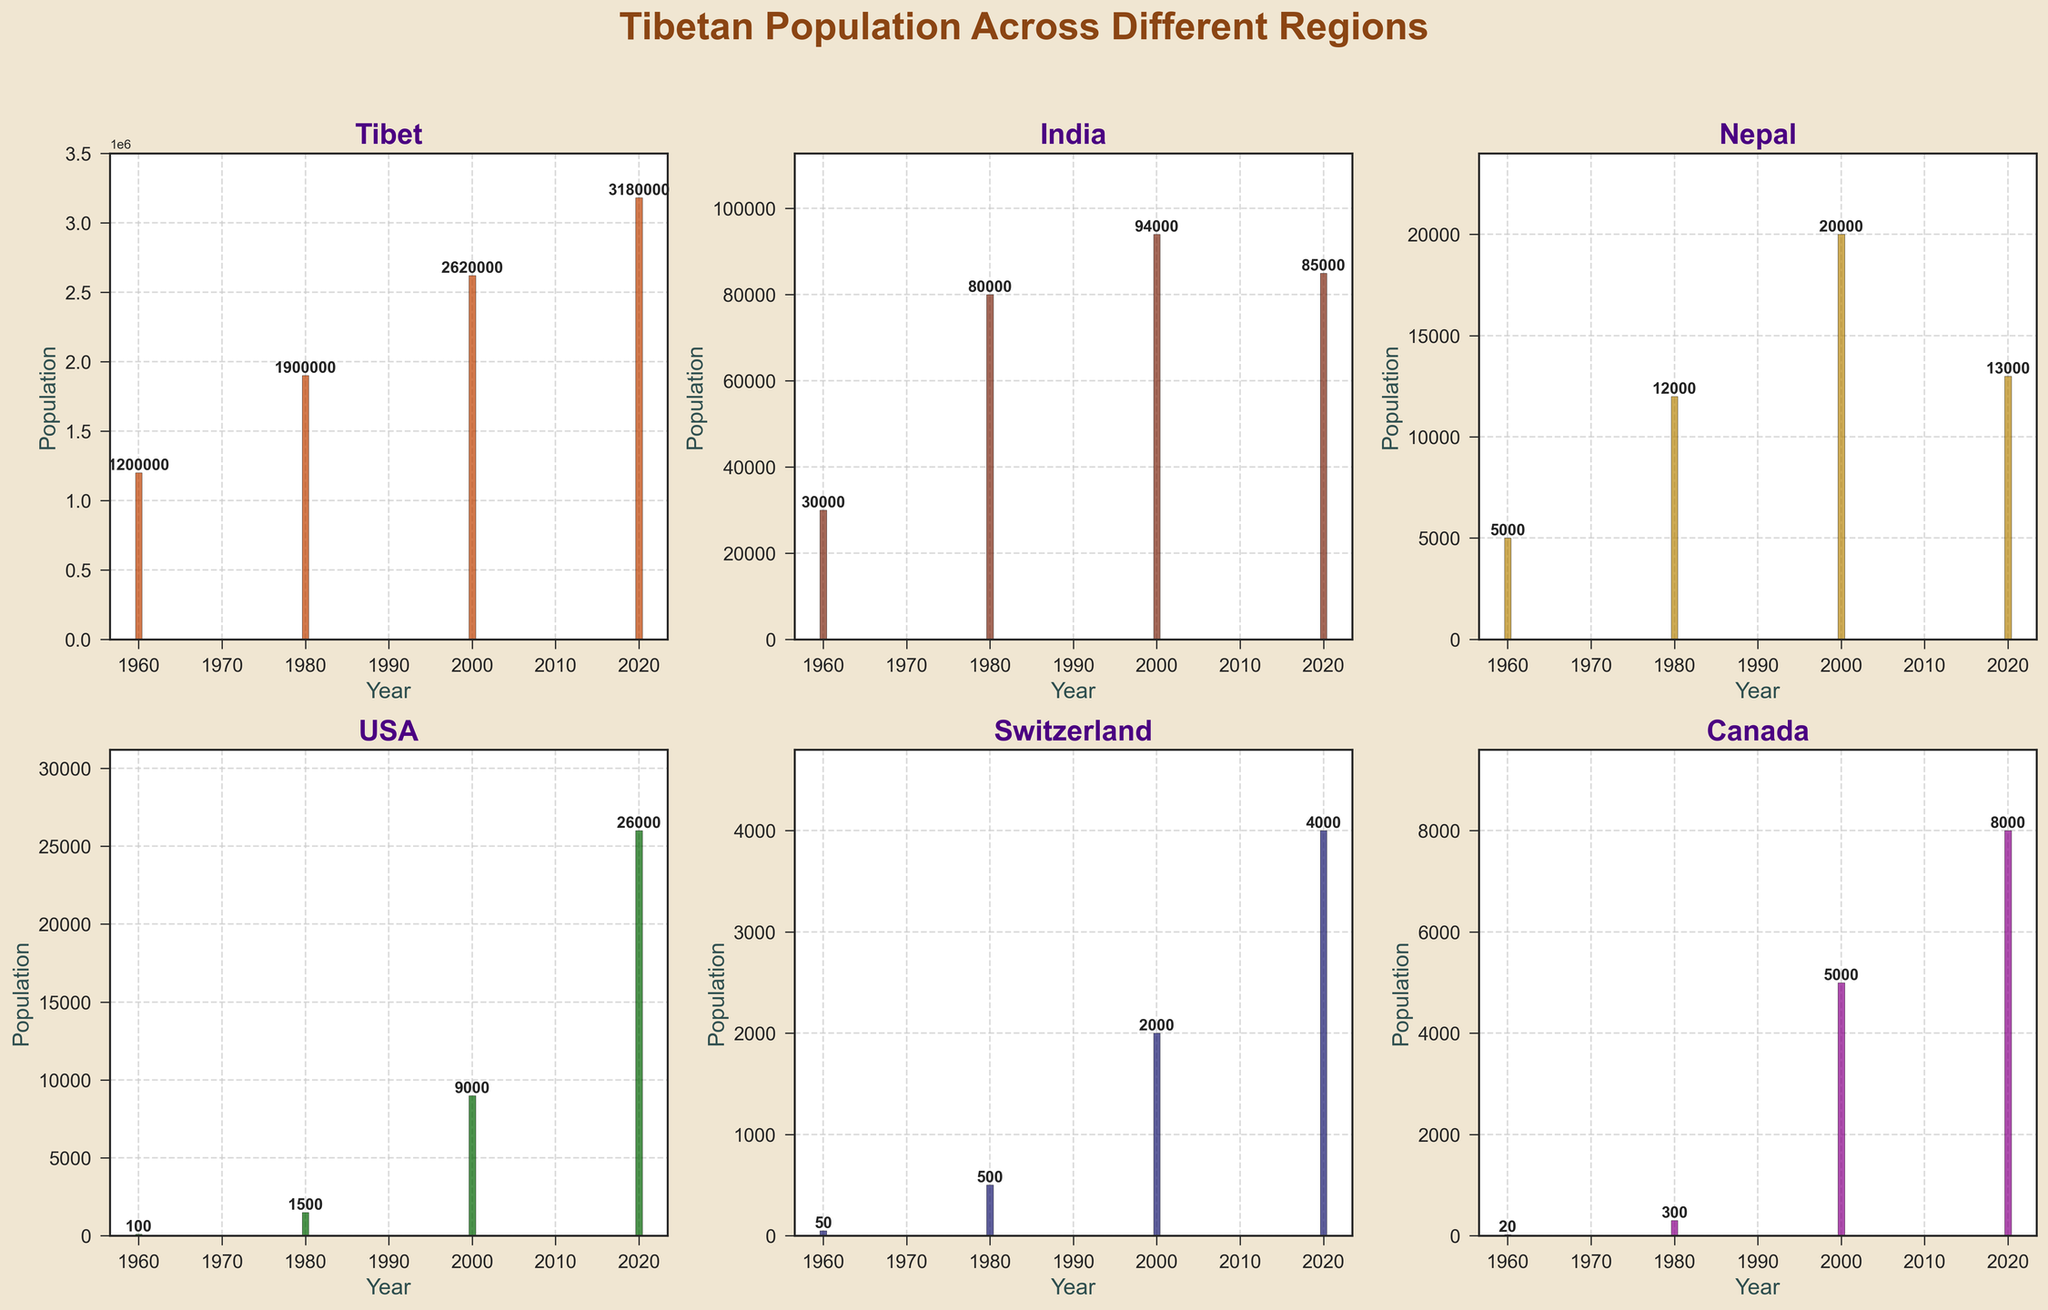What is the title of the figure? The title is usually located at the top-center of the figure.
Answer: Tibetan Population Across Different Regions How many years are represented in the figure? By counting the bars or labels on the x-axis across all subplots, we see there are four distinct years.
Answer: Four (1960, 1980, 2000, 2020) Which region had the highest population in 1980? Each subplot represents a different region, and we can compare the heights of the bars for 1980. Tibet has the tallest bar for that year.
Answer: Tibet What's the population of Tibet in 2020 according to the figure? By looking at the "Tibet" subplot and checking the label at the top of the 2020 bar.
Answer: 3,180,000 Compare the Tibetan population in India and Nepal in 2000. Which was higher, and by how much? Look at the bars representing the year 2000 in the subplots for India and Nepal, then subtract the values. India has 94,000, Nepal has 20,000.
Answer: India was higher by 74,000 What is the change in Tibetan population in the USA from 1980 to 2020? Check the population values in the USA subplot for the years 1980 and 2020. Subtract 1,500 (1980) from 26,000 (2020).
Answer: Increased by 24,500 Which region experienced the biggest population increase from 1960 to 2020? Compare the differences in population values between 1960 and 2020 for each region. Tibet shows the greatest increase.
Answer: Tibet What is the combined population of Tibetan communities in Switzerland and Canada in 2020? Look at the 2020 bars for Switzerland and Canada, then sum the values: 4,000 (Switzerland) + 8,000 (Canada).
Answer: 12,000 Has the Tibetan population in Nepal ever been higher than in India in any of the years represented? Compare the height of the bars in the Nepal subplot with those in the India subplot for each year.
Answer: No What trend do you notice about the Tibetan population in Tibet from 1960 to 2020? By observing the increasing height of the bars over the years in the Tibet subplot, the trend shows a steady rise in population.
Answer: Steady increase 